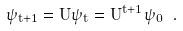<formula> <loc_0><loc_0><loc_500><loc_500>\psi _ { t + 1 } = U \psi _ { t } = U ^ { t + 1 } \psi _ { 0 } \ .</formula> 